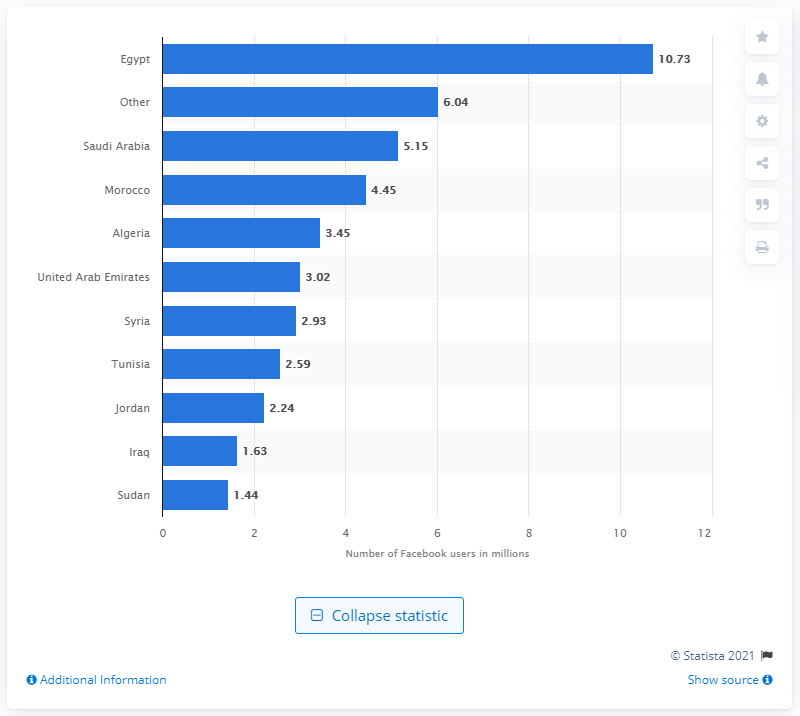Highlight a few significant elements in this photo. As of June 2012, there were approximately 10.73 million Facebook users in Egypt. 